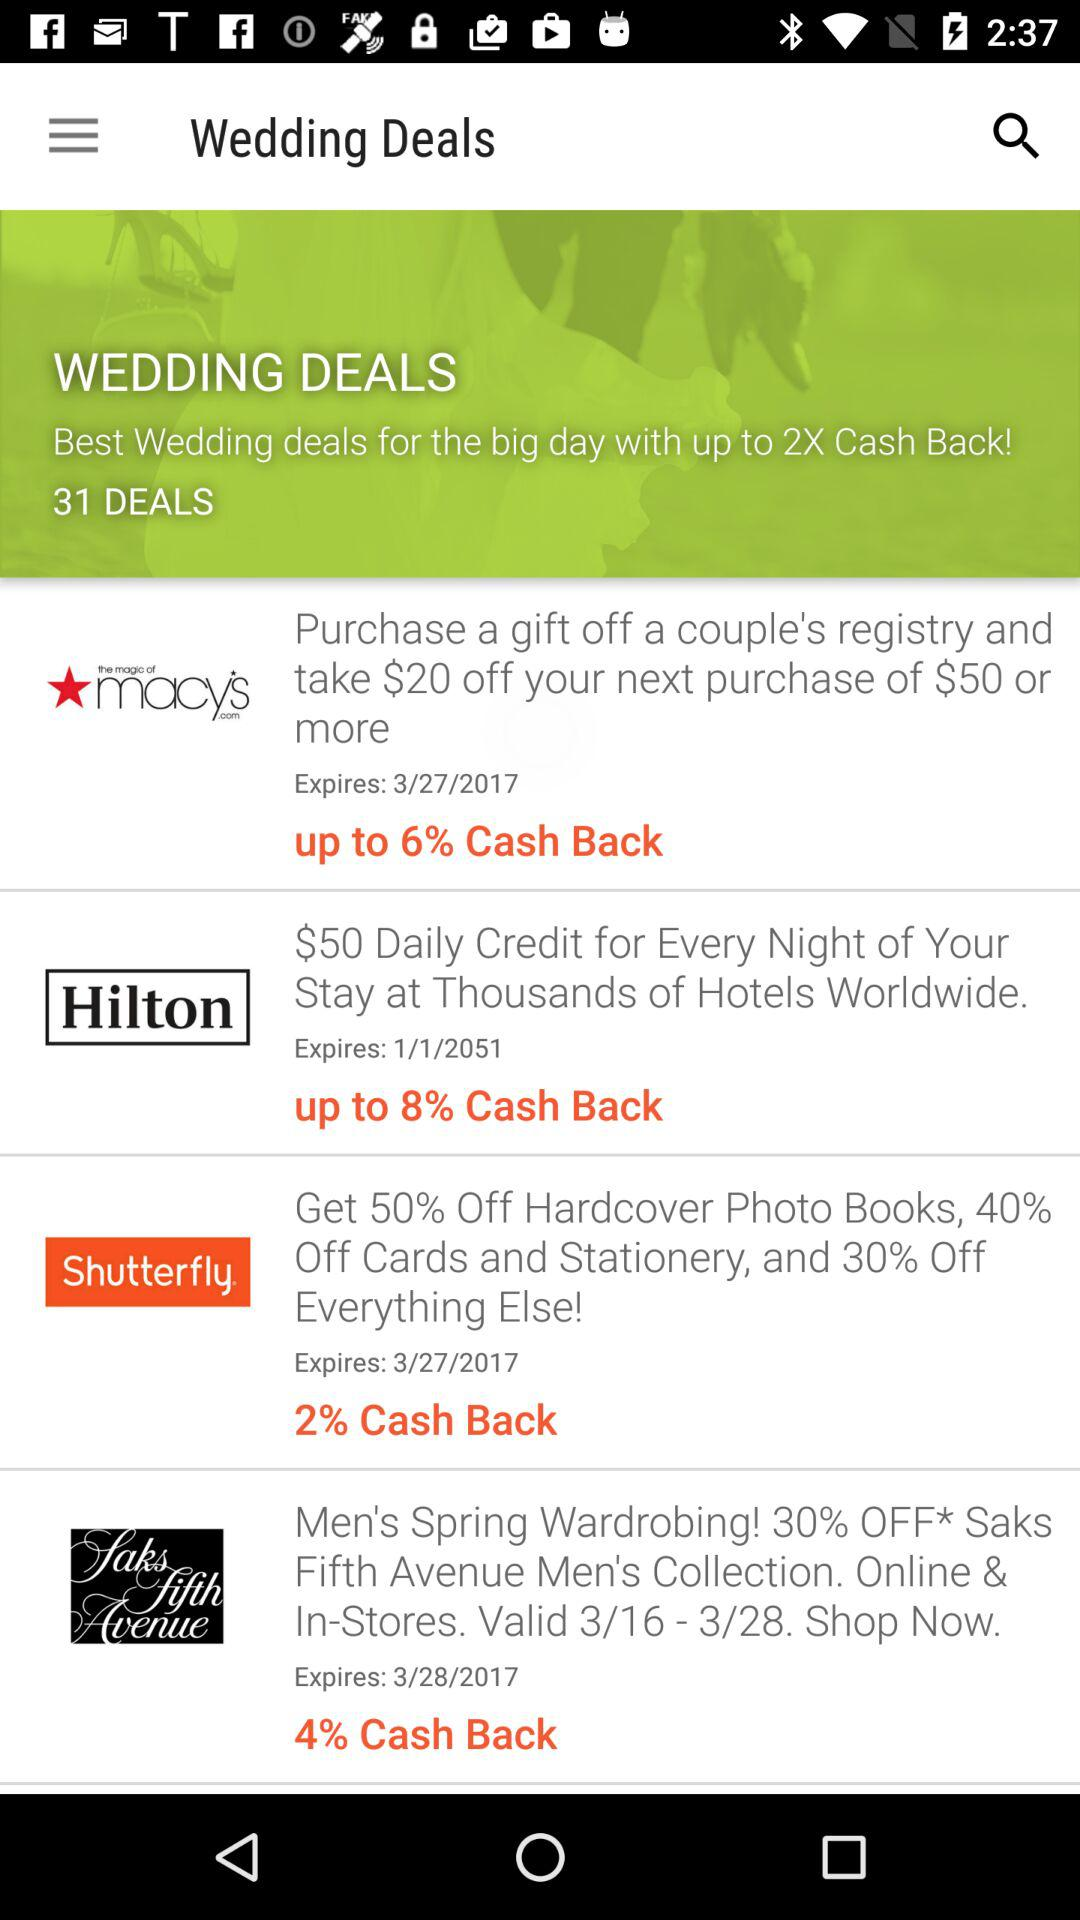Where is the nearest Hilton located?
When the provided information is insufficient, respond with <no answer>. <no answer> 